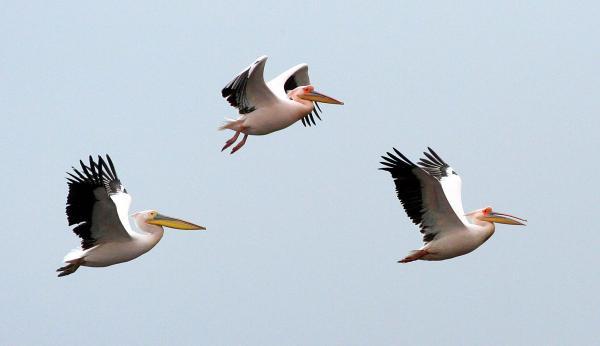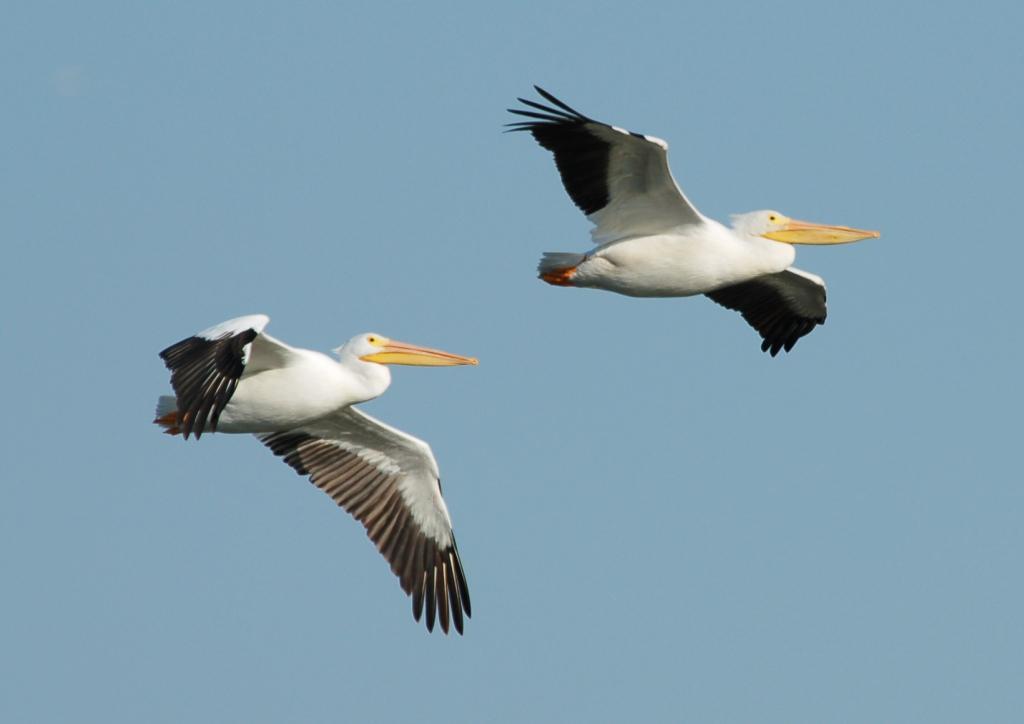The first image is the image on the left, the second image is the image on the right. Examine the images to the left and right. Is the description "Two birds are flying to the left in the image on the left." accurate? Answer yes or no. No. The first image is the image on the left, the second image is the image on the right. For the images shown, is this caption "All of the birds in both images are flying rightward." true? Answer yes or no. Yes. 